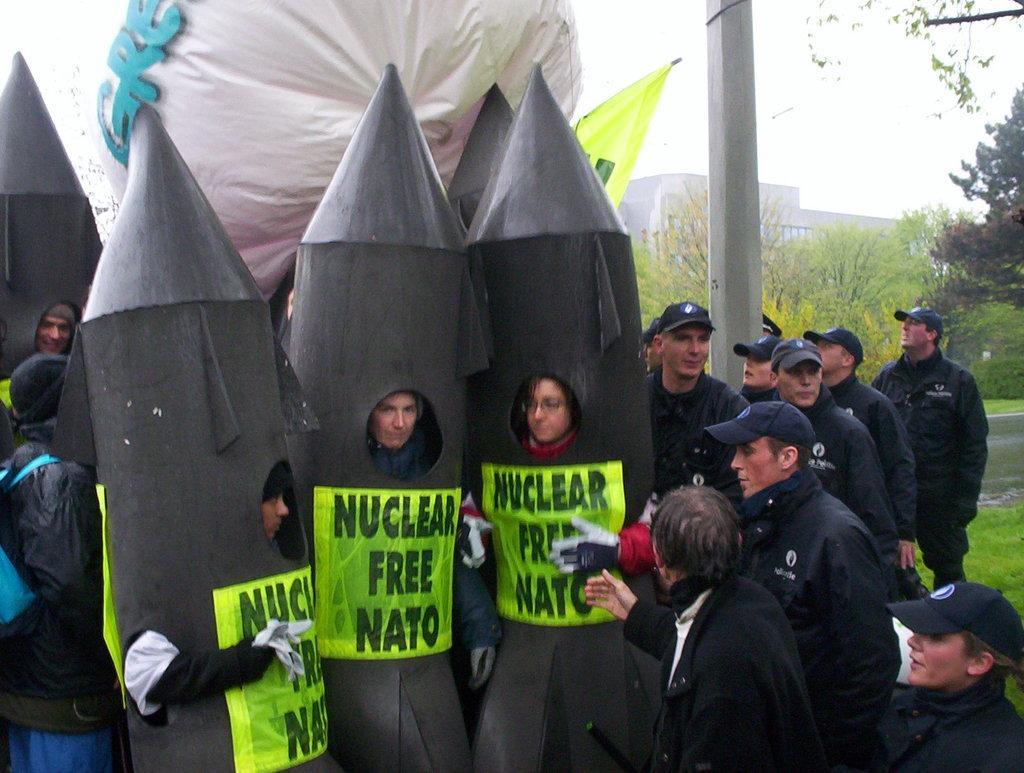Describe this image in one or two sentences. In this picture there are three boy wearing black color rocket costume dress and standing in the front. Behind there are some men wearing black color shirt and caps standing beside them. In the background there are some trees and brown color building. 